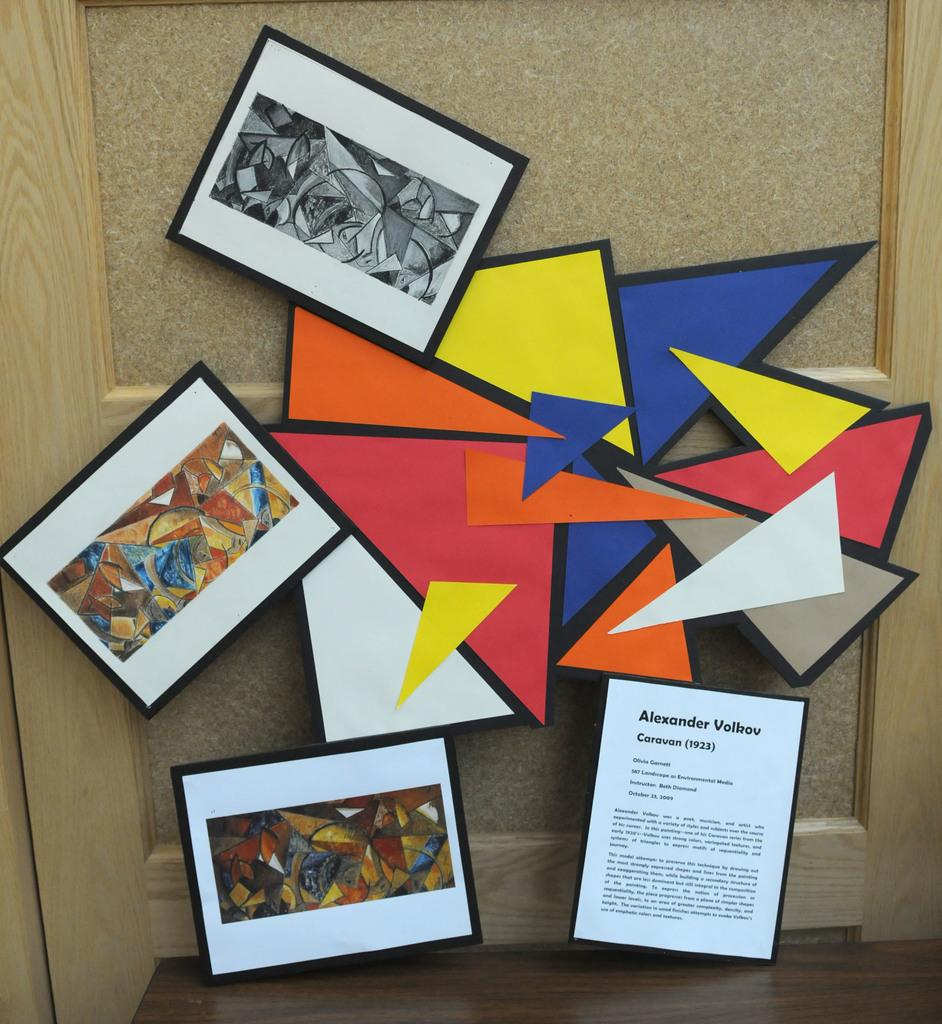<image>
Share a concise interpretation of the image provided. A colorful display of shapes connecting three framed printed pictures by Alexander Volkov. 